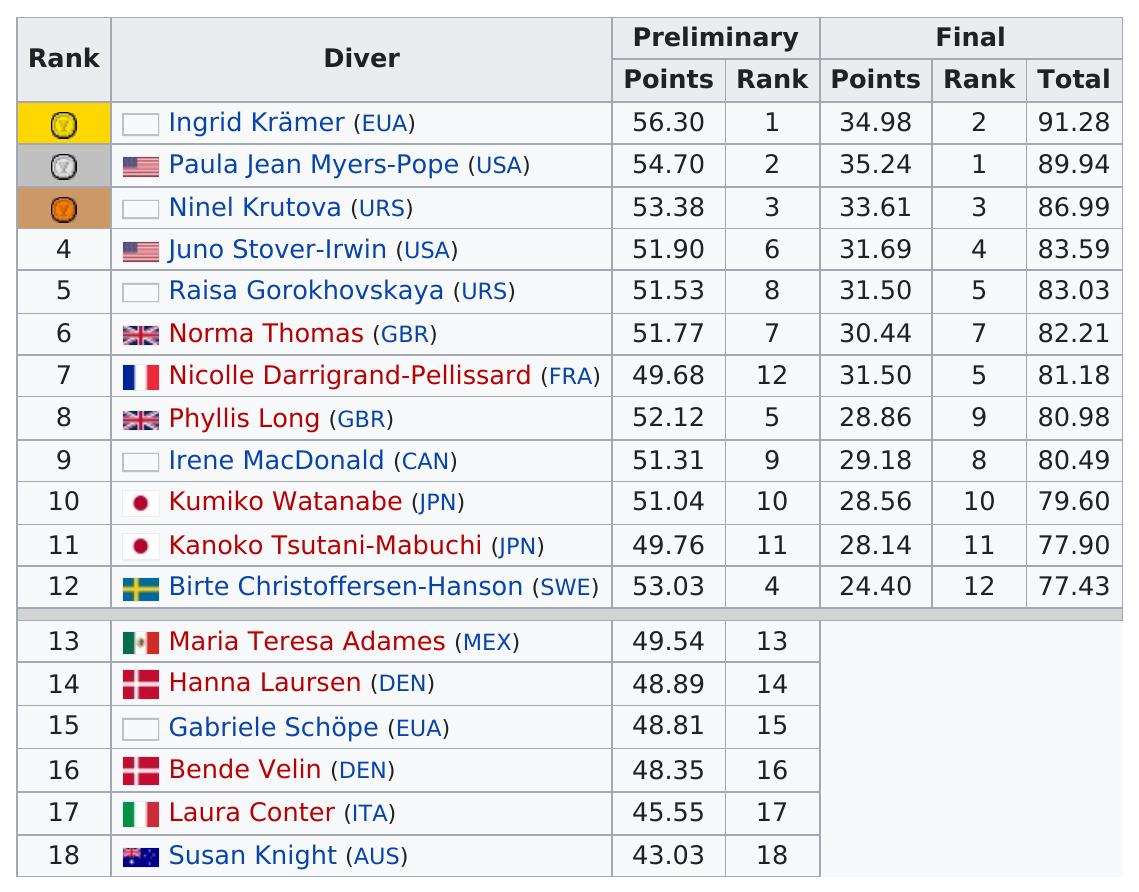List a handful of essential elements in this visual. Eighteen drivers participated in the preliminary round. The difference in total score between first and second place is 1.34. Paula Jean Myers-Pope, who is a citizen of the United States, is the person who shares the same nationality as Juno Stover-Irwin. Ingrid Krämer scored a total of 34.98 points in the final. Paula Jean Myers-Pope, an American diver, is listed before Ninel Krutova in the record. 